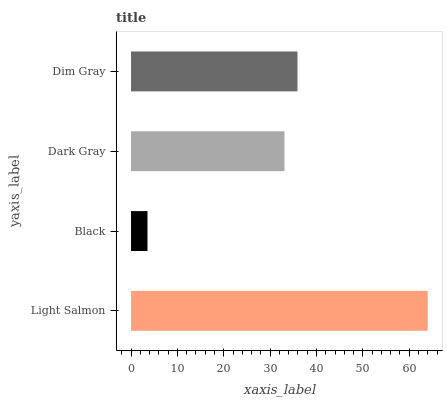Is Black the minimum?
Answer yes or no. Yes. Is Light Salmon the maximum?
Answer yes or no. Yes. Is Dark Gray the minimum?
Answer yes or no. No. Is Dark Gray the maximum?
Answer yes or no. No. Is Dark Gray greater than Black?
Answer yes or no. Yes. Is Black less than Dark Gray?
Answer yes or no. Yes. Is Black greater than Dark Gray?
Answer yes or no. No. Is Dark Gray less than Black?
Answer yes or no. No. Is Dim Gray the high median?
Answer yes or no. Yes. Is Dark Gray the low median?
Answer yes or no. Yes. Is Light Salmon the high median?
Answer yes or no. No. Is Dim Gray the low median?
Answer yes or no. No. 